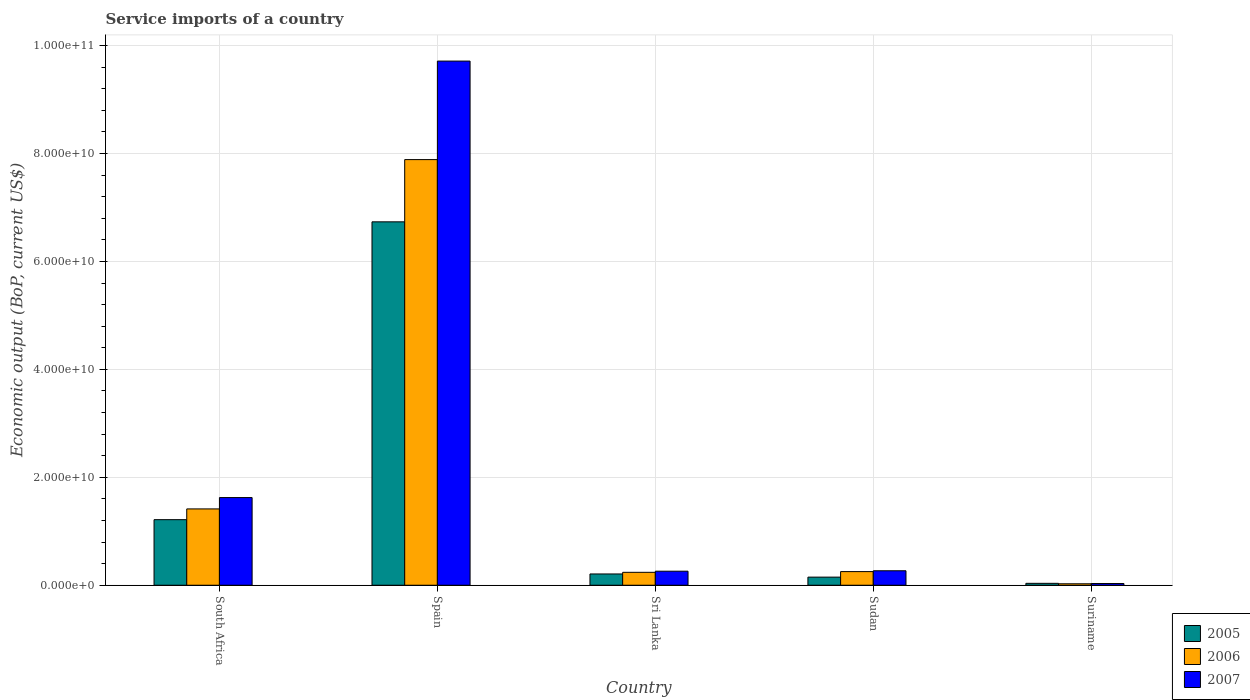How many different coloured bars are there?
Give a very brief answer. 3. Are the number of bars per tick equal to the number of legend labels?
Give a very brief answer. Yes. Are the number of bars on each tick of the X-axis equal?
Your answer should be very brief. Yes. How many bars are there on the 3rd tick from the right?
Your answer should be very brief. 3. What is the label of the 5th group of bars from the left?
Make the answer very short. Suriname. What is the service imports in 2005 in Sri Lanka?
Ensure brevity in your answer.  2.09e+09. Across all countries, what is the maximum service imports in 2007?
Give a very brief answer. 9.71e+1. Across all countries, what is the minimum service imports in 2006?
Keep it short and to the point. 2.69e+08. In which country was the service imports in 2005 maximum?
Provide a succinct answer. Spain. In which country was the service imports in 2005 minimum?
Your response must be concise. Suriname. What is the total service imports in 2006 in the graph?
Ensure brevity in your answer.  9.82e+1. What is the difference between the service imports in 2006 in South Africa and that in Sudan?
Give a very brief answer. 1.16e+1. What is the difference between the service imports in 2006 in Spain and the service imports in 2007 in Sudan?
Your answer should be very brief. 7.62e+1. What is the average service imports in 2005 per country?
Provide a short and direct response. 1.67e+1. What is the difference between the service imports of/in 2006 and service imports of/in 2005 in Spain?
Your answer should be very brief. 1.15e+1. In how many countries, is the service imports in 2007 greater than 88000000000 US$?
Make the answer very short. 1. What is the ratio of the service imports in 2006 in South Africa to that in Sri Lanka?
Keep it short and to the point. 5.91. Is the service imports in 2007 in South Africa less than that in Sri Lanka?
Provide a short and direct response. No. Is the difference between the service imports in 2006 in South Africa and Sudan greater than the difference between the service imports in 2005 in South Africa and Sudan?
Keep it short and to the point. Yes. What is the difference between the highest and the second highest service imports in 2005?
Offer a very short reply. 6.53e+1. What is the difference between the highest and the lowest service imports in 2006?
Your answer should be very brief. 7.86e+1. In how many countries, is the service imports in 2005 greater than the average service imports in 2005 taken over all countries?
Provide a short and direct response. 1. What does the 1st bar from the left in Sri Lanka represents?
Keep it short and to the point. 2005. What does the 3rd bar from the right in Sudan represents?
Your answer should be very brief. 2005. Is it the case that in every country, the sum of the service imports in 2006 and service imports in 2005 is greater than the service imports in 2007?
Your answer should be compact. Yes. How many countries are there in the graph?
Offer a very short reply. 5. What is the difference between two consecutive major ticks on the Y-axis?
Ensure brevity in your answer.  2.00e+1. Are the values on the major ticks of Y-axis written in scientific E-notation?
Your answer should be compact. Yes. Does the graph contain any zero values?
Your response must be concise. No. Does the graph contain grids?
Offer a very short reply. Yes. What is the title of the graph?
Your answer should be compact. Service imports of a country. Does "1976" appear as one of the legend labels in the graph?
Your response must be concise. No. What is the label or title of the X-axis?
Provide a short and direct response. Country. What is the label or title of the Y-axis?
Keep it short and to the point. Economic output (BoP, current US$). What is the Economic output (BoP, current US$) of 2005 in South Africa?
Your answer should be very brief. 1.22e+1. What is the Economic output (BoP, current US$) of 2006 in South Africa?
Your answer should be compact. 1.41e+1. What is the Economic output (BoP, current US$) in 2007 in South Africa?
Offer a terse response. 1.62e+1. What is the Economic output (BoP, current US$) in 2005 in Spain?
Your response must be concise. 6.73e+1. What is the Economic output (BoP, current US$) in 2006 in Spain?
Your response must be concise. 7.89e+1. What is the Economic output (BoP, current US$) in 2007 in Spain?
Provide a succinct answer. 9.71e+1. What is the Economic output (BoP, current US$) of 2005 in Sri Lanka?
Make the answer very short. 2.09e+09. What is the Economic output (BoP, current US$) in 2006 in Sri Lanka?
Offer a terse response. 2.39e+09. What is the Economic output (BoP, current US$) of 2007 in Sri Lanka?
Provide a short and direct response. 2.60e+09. What is the Economic output (BoP, current US$) of 2005 in Sudan?
Give a very brief answer. 1.50e+09. What is the Economic output (BoP, current US$) of 2006 in Sudan?
Ensure brevity in your answer.  2.53e+09. What is the Economic output (BoP, current US$) in 2007 in Sudan?
Your answer should be very brief. 2.68e+09. What is the Economic output (BoP, current US$) in 2005 in Suriname?
Give a very brief answer. 3.52e+08. What is the Economic output (BoP, current US$) in 2006 in Suriname?
Keep it short and to the point. 2.69e+08. What is the Economic output (BoP, current US$) of 2007 in Suriname?
Your response must be concise. 3.18e+08. Across all countries, what is the maximum Economic output (BoP, current US$) of 2005?
Make the answer very short. 6.73e+1. Across all countries, what is the maximum Economic output (BoP, current US$) in 2006?
Your answer should be compact. 7.89e+1. Across all countries, what is the maximum Economic output (BoP, current US$) of 2007?
Your answer should be compact. 9.71e+1. Across all countries, what is the minimum Economic output (BoP, current US$) of 2005?
Your answer should be very brief. 3.52e+08. Across all countries, what is the minimum Economic output (BoP, current US$) of 2006?
Your answer should be compact. 2.69e+08. Across all countries, what is the minimum Economic output (BoP, current US$) of 2007?
Ensure brevity in your answer.  3.18e+08. What is the total Economic output (BoP, current US$) of 2005 in the graph?
Your answer should be very brief. 8.34e+1. What is the total Economic output (BoP, current US$) in 2006 in the graph?
Your answer should be very brief. 9.82e+1. What is the total Economic output (BoP, current US$) in 2007 in the graph?
Give a very brief answer. 1.19e+11. What is the difference between the Economic output (BoP, current US$) in 2005 in South Africa and that in Spain?
Your answer should be compact. -5.52e+1. What is the difference between the Economic output (BoP, current US$) in 2006 in South Africa and that in Spain?
Provide a succinct answer. -6.47e+1. What is the difference between the Economic output (BoP, current US$) in 2007 in South Africa and that in Spain?
Your response must be concise. -8.09e+1. What is the difference between the Economic output (BoP, current US$) of 2005 in South Africa and that in Sri Lanka?
Your response must be concise. 1.01e+1. What is the difference between the Economic output (BoP, current US$) of 2006 in South Africa and that in Sri Lanka?
Ensure brevity in your answer.  1.18e+1. What is the difference between the Economic output (BoP, current US$) in 2007 in South Africa and that in Sri Lanka?
Provide a short and direct response. 1.36e+1. What is the difference between the Economic output (BoP, current US$) of 2005 in South Africa and that in Sudan?
Your response must be concise. 1.06e+1. What is the difference between the Economic output (BoP, current US$) of 2006 in South Africa and that in Sudan?
Offer a very short reply. 1.16e+1. What is the difference between the Economic output (BoP, current US$) in 2007 in South Africa and that in Sudan?
Give a very brief answer. 1.36e+1. What is the difference between the Economic output (BoP, current US$) in 2005 in South Africa and that in Suriname?
Your response must be concise. 1.18e+1. What is the difference between the Economic output (BoP, current US$) in 2006 in South Africa and that in Suriname?
Give a very brief answer. 1.39e+1. What is the difference between the Economic output (BoP, current US$) of 2007 in South Africa and that in Suriname?
Your response must be concise. 1.59e+1. What is the difference between the Economic output (BoP, current US$) in 2005 in Spain and that in Sri Lanka?
Your answer should be very brief. 6.53e+1. What is the difference between the Economic output (BoP, current US$) of 2006 in Spain and that in Sri Lanka?
Your response must be concise. 7.65e+1. What is the difference between the Economic output (BoP, current US$) in 2007 in Spain and that in Sri Lanka?
Your response must be concise. 9.45e+1. What is the difference between the Economic output (BoP, current US$) in 2005 in Spain and that in Sudan?
Your answer should be compact. 6.58e+1. What is the difference between the Economic output (BoP, current US$) in 2006 in Spain and that in Sudan?
Provide a short and direct response. 7.64e+1. What is the difference between the Economic output (BoP, current US$) of 2007 in Spain and that in Sudan?
Give a very brief answer. 9.45e+1. What is the difference between the Economic output (BoP, current US$) in 2005 in Spain and that in Suriname?
Your answer should be very brief. 6.70e+1. What is the difference between the Economic output (BoP, current US$) in 2006 in Spain and that in Suriname?
Your answer should be very brief. 7.86e+1. What is the difference between the Economic output (BoP, current US$) in 2007 in Spain and that in Suriname?
Provide a short and direct response. 9.68e+1. What is the difference between the Economic output (BoP, current US$) of 2005 in Sri Lanka and that in Sudan?
Offer a terse response. 5.86e+08. What is the difference between the Economic output (BoP, current US$) of 2006 in Sri Lanka and that in Sudan?
Keep it short and to the point. -1.32e+08. What is the difference between the Economic output (BoP, current US$) in 2007 in Sri Lanka and that in Sudan?
Make the answer very short. -7.95e+07. What is the difference between the Economic output (BoP, current US$) in 2005 in Sri Lanka and that in Suriname?
Provide a succinct answer. 1.74e+09. What is the difference between the Economic output (BoP, current US$) in 2006 in Sri Lanka and that in Suriname?
Give a very brief answer. 2.12e+09. What is the difference between the Economic output (BoP, current US$) of 2007 in Sri Lanka and that in Suriname?
Make the answer very short. 2.28e+09. What is the difference between the Economic output (BoP, current US$) in 2005 in Sudan and that in Suriname?
Your answer should be very brief. 1.15e+09. What is the difference between the Economic output (BoP, current US$) in 2006 in Sudan and that in Suriname?
Ensure brevity in your answer.  2.26e+09. What is the difference between the Economic output (BoP, current US$) in 2007 in Sudan and that in Suriname?
Give a very brief answer. 2.36e+09. What is the difference between the Economic output (BoP, current US$) of 2005 in South Africa and the Economic output (BoP, current US$) of 2006 in Spain?
Your answer should be compact. -6.67e+1. What is the difference between the Economic output (BoP, current US$) of 2005 in South Africa and the Economic output (BoP, current US$) of 2007 in Spain?
Make the answer very short. -8.50e+1. What is the difference between the Economic output (BoP, current US$) in 2006 in South Africa and the Economic output (BoP, current US$) in 2007 in Spain?
Your answer should be compact. -8.30e+1. What is the difference between the Economic output (BoP, current US$) in 2005 in South Africa and the Economic output (BoP, current US$) in 2006 in Sri Lanka?
Make the answer very short. 9.76e+09. What is the difference between the Economic output (BoP, current US$) in 2005 in South Africa and the Economic output (BoP, current US$) in 2007 in Sri Lanka?
Provide a succinct answer. 9.55e+09. What is the difference between the Economic output (BoP, current US$) in 2006 in South Africa and the Economic output (BoP, current US$) in 2007 in Sri Lanka?
Provide a short and direct response. 1.15e+1. What is the difference between the Economic output (BoP, current US$) in 2005 in South Africa and the Economic output (BoP, current US$) in 2006 in Sudan?
Make the answer very short. 9.63e+09. What is the difference between the Economic output (BoP, current US$) of 2005 in South Africa and the Economic output (BoP, current US$) of 2007 in Sudan?
Provide a succinct answer. 9.47e+09. What is the difference between the Economic output (BoP, current US$) in 2006 in South Africa and the Economic output (BoP, current US$) in 2007 in Sudan?
Give a very brief answer. 1.15e+1. What is the difference between the Economic output (BoP, current US$) of 2005 in South Africa and the Economic output (BoP, current US$) of 2006 in Suriname?
Make the answer very short. 1.19e+1. What is the difference between the Economic output (BoP, current US$) in 2005 in South Africa and the Economic output (BoP, current US$) in 2007 in Suriname?
Give a very brief answer. 1.18e+1. What is the difference between the Economic output (BoP, current US$) in 2006 in South Africa and the Economic output (BoP, current US$) in 2007 in Suriname?
Offer a very short reply. 1.38e+1. What is the difference between the Economic output (BoP, current US$) in 2005 in Spain and the Economic output (BoP, current US$) in 2006 in Sri Lanka?
Your response must be concise. 6.49e+1. What is the difference between the Economic output (BoP, current US$) in 2005 in Spain and the Economic output (BoP, current US$) in 2007 in Sri Lanka?
Keep it short and to the point. 6.47e+1. What is the difference between the Economic output (BoP, current US$) of 2006 in Spain and the Economic output (BoP, current US$) of 2007 in Sri Lanka?
Offer a very short reply. 7.63e+1. What is the difference between the Economic output (BoP, current US$) in 2005 in Spain and the Economic output (BoP, current US$) in 2006 in Sudan?
Your response must be concise. 6.48e+1. What is the difference between the Economic output (BoP, current US$) in 2005 in Spain and the Economic output (BoP, current US$) in 2007 in Sudan?
Give a very brief answer. 6.47e+1. What is the difference between the Economic output (BoP, current US$) of 2006 in Spain and the Economic output (BoP, current US$) of 2007 in Sudan?
Your answer should be compact. 7.62e+1. What is the difference between the Economic output (BoP, current US$) of 2005 in Spain and the Economic output (BoP, current US$) of 2006 in Suriname?
Give a very brief answer. 6.71e+1. What is the difference between the Economic output (BoP, current US$) of 2005 in Spain and the Economic output (BoP, current US$) of 2007 in Suriname?
Make the answer very short. 6.70e+1. What is the difference between the Economic output (BoP, current US$) in 2006 in Spain and the Economic output (BoP, current US$) in 2007 in Suriname?
Ensure brevity in your answer.  7.86e+1. What is the difference between the Economic output (BoP, current US$) in 2005 in Sri Lanka and the Economic output (BoP, current US$) in 2006 in Sudan?
Make the answer very short. -4.37e+08. What is the difference between the Economic output (BoP, current US$) of 2005 in Sri Lanka and the Economic output (BoP, current US$) of 2007 in Sudan?
Your response must be concise. -5.93e+08. What is the difference between the Economic output (BoP, current US$) of 2006 in Sri Lanka and the Economic output (BoP, current US$) of 2007 in Sudan?
Give a very brief answer. -2.88e+08. What is the difference between the Economic output (BoP, current US$) in 2005 in Sri Lanka and the Economic output (BoP, current US$) in 2006 in Suriname?
Give a very brief answer. 1.82e+09. What is the difference between the Economic output (BoP, current US$) of 2005 in Sri Lanka and the Economic output (BoP, current US$) of 2007 in Suriname?
Provide a succinct answer. 1.77e+09. What is the difference between the Economic output (BoP, current US$) in 2006 in Sri Lanka and the Economic output (BoP, current US$) in 2007 in Suriname?
Your answer should be compact. 2.08e+09. What is the difference between the Economic output (BoP, current US$) in 2005 in Sudan and the Economic output (BoP, current US$) in 2006 in Suriname?
Your answer should be very brief. 1.23e+09. What is the difference between the Economic output (BoP, current US$) in 2005 in Sudan and the Economic output (BoP, current US$) in 2007 in Suriname?
Your answer should be very brief. 1.19e+09. What is the difference between the Economic output (BoP, current US$) of 2006 in Sudan and the Economic output (BoP, current US$) of 2007 in Suriname?
Your answer should be very brief. 2.21e+09. What is the average Economic output (BoP, current US$) of 2005 per country?
Provide a succinct answer. 1.67e+1. What is the average Economic output (BoP, current US$) in 2006 per country?
Your answer should be very brief. 1.96e+1. What is the average Economic output (BoP, current US$) of 2007 per country?
Provide a short and direct response. 2.38e+1. What is the difference between the Economic output (BoP, current US$) of 2005 and Economic output (BoP, current US$) of 2006 in South Africa?
Your response must be concise. -1.99e+09. What is the difference between the Economic output (BoP, current US$) in 2005 and Economic output (BoP, current US$) in 2007 in South Africa?
Make the answer very short. -4.09e+09. What is the difference between the Economic output (BoP, current US$) of 2006 and Economic output (BoP, current US$) of 2007 in South Africa?
Your answer should be very brief. -2.10e+09. What is the difference between the Economic output (BoP, current US$) of 2005 and Economic output (BoP, current US$) of 2006 in Spain?
Your answer should be compact. -1.15e+1. What is the difference between the Economic output (BoP, current US$) of 2005 and Economic output (BoP, current US$) of 2007 in Spain?
Provide a succinct answer. -2.98e+1. What is the difference between the Economic output (BoP, current US$) in 2006 and Economic output (BoP, current US$) in 2007 in Spain?
Offer a very short reply. -1.83e+1. What is the difference between the Economic output (BoP, current US$) of 2005 and Economic output (BoP, current US$) of 2006 in Sri Lanka?
Your answer should be very brief. -3.05e+08. What is the difference between the Economic output (BoP, current US$) of 2005 and Economic output (BoP, current US$) of 2007 in Sri Lanka?
Provide a succinct answer. -5.13e+08. What is the difference between the Economic output (BoP, current US$) of 2006 and Economic output (BoP, current US$) of 2007 in Sri Lanka?
Make the answer very short. -2.08e+08. What is the difference between the Economic output (BoP, current US$) in 2005 and Economic output (BoP, current US$) in 2006 in Sudan?
Provide a short and direct response. -1.02e+09. What is the difference between the Economic output (BoP, current US$) in 2005 and Economic output (BoP, current US$) in 2007 in Sudan?
Make the answer very short. -1.18e+09. What is the difference between the Economic output (BoP, current US$) of 2006 and Economic output (BoP, current US$) of 2007 in Sudan?
Your answer should be very brief. -1.55e+08. What is the difference between the Economic output (BoP, current US$) in 2005 and Economic output (BoP, current US$) in 2006 in Suriname?
Offer a terse response. 8.25e+07. What is the difference between the Economic output (BoP, current US$) of 2005 and Economic output (BoP, current US$) of 2007 in Suriname?
Offer a terse response. 3.39e+07. What is the difference between the Economic output (BoP, current US$) in 2006 and Economic output (BoP, current US$) in 2007 in Suriname?
Your answer should be compact. -4.86e+07. What is the ratio of the Economic output (BoP, current US$) in 2005 in South Africa to that in Spain?
Ensure brevity in your answer.  0.18. What is the ratio of the Economic output (BoP, current US$) in 2006 in South Africa to that in Spain?
Provide a succinct answer. 0.18. What is the ratio of the Economic output (BoP, current US$) in 2007 in South Africa to that in Spain?
Keep it short and to the point. 0.17. What is the ratio of the Economic output (BoP, current US$) of 2005 in South Africa to that in Sri Lanka?
Provide a succinct answer. 5.82. What is the ratio of the Economic output (BoP, current US$) in 2006 in South Africa to that in Sri Lanka?
Your answer should be compact. 5.91. What is the ratio of the Economic output (BoP, current US$) of 2007 in South Africa to that in Sri Lanka?
Provide a short and direct response. 6.24. What is the ratio of the Economic output (BoP, current US$) of 2005 in South Africa to that in Sudan?
Ensure brevity in your answer.  8.08. What is the ratio of the Economic output (BoP, current US$) in 2006 in South Africa to that in Sudan?
Your answer should be very brief. 5.6. What is the ratio of the Economic output (BoP, current US$) of 2007 in South Africa to that in Sudan?
Make the answer very short. 6.06. What is the ratio of the Economic output (BoP, current US$) of 2005 in South Africa to that in Suriname?
Provide a succinct answer. 34.54. What is the ratio of the Economic output (BoP, current US$) of 2006 in South Africa to that in Suriname?
Make the answer very short. 52.52. What is the ratio of the Economic output (BoP, current US$) in 2007 in South Africa to that in Suriname?
Offer a very short reply. 51.1. What is the ratio of the Economic output (BoP, current US$) in 2005 in Spain to that in Sri Lanka?
Provide a succinct answer. 32.24. What is the ratio of the Economic output (BoP, current US$) in 2006 in Spain to that in Sri Lanka?
Offer a terse response. 32.95. What is the ratio of the Economic output (BoP, current US$) in 2007 in Spain to that in Sri Lanka?
Provide a succinct answer. 37.33. What is the ratio of the Economic output (BoP, current US$) of 2005 in Spain to that in Sudan?
Provide a succinct answer. 44.81. What is the ratio of the Economic output (BoP, current US$) in 2006 in Spain to that in Sudan?
Provide a short and direct response. 31.23. What is the ratio of the Economic output (BoP, current US$) of 2007 in Spain to that in Sudan?
Make the answer very short. 36.23. What is the ratio of the Economic output (BoP, current US$) of 2005 in Spain to that in Suriname?
Ensure brevity in your answer.  191.42. What is the ratio of the Economic output (BoP, current US$) in 2006 in Spain to that in Suriname?
Ensure brevity in your answer.  292.89. What is the ratio of the Economic output (BoP, current US$) of 2007 in Spain to that in Suriname?
Your answer should be compact. 305.54. What is the ratio of the Economic output (BoP, current US$) in 2005 in Sri Lanka to that in Sudan?
Provide a short and direct response. 1.39. What is the ratio of the Economic output (BoP, current US$) of 2006 in Sri Lanka to that in Sudan?
Provide a succinct answer. 0.95. What is the ratio of the Economic output (BoP, current US$) in 2007 in Sri Lanka to that in Sudan?
Offer a very short reply. 0.97. What is the ratio of the Economic output (BoP, current US$) in 2005 in Sri Lanka to that in Suriname?
Provide a succinct answer. 5.94. What is the ratio of the Economic output (BoP, current US$) of 2006 in Sri Lanka to that in Suriname?
Offer a terse response. 8.89. What is the ratio of the Economic output (BoP, current US$) of 2007 in Sri Lanka to that in Suriname?
Ensure brevity in your answer.  8.18. What is the ratio of the Economic output (BoP, current US$) in 2005 in Sudan to that in Suriname?
Offer a very short reply. 4.27. What is the ratio of the Economic output (BoP, current US$) in 2006 in Sudan to that in Suriname?
Keep it short and to the point. 9.38. What is the ratio of the Economic output (BoP, current US$) in 2007 in Sudan to that in Suriname?
Make the answer very short. 8.43. What is the difference between the highest and the second highest Economic output (BoP, current US$) in 2005?
Ensure brevity in your answer.  5.52e+1. What is the difference between the highest and the second highest Economic output (BoP, current US$) of 2006?
Your answer should be compact. 6.47e+1. What is the difference between the highest and the second highest Economic output (BoP, current US$) in 2007?
Keep it short and to the point. 8.09e+1. What is the difference between the highest and the lowest Economic output (BoP, current US$) of 2005?
Keep it short and to the point. 6.70e+1. What is the difference between the highest and the lowest Economic output (BoP, current US$) in 2006?
Provide a short and direct response. 7.86e+1. What is the difference between the highest and the lowest Economic output (BoP, current US$) of 2007?
Provide a succinct answer. 9.68e+1. 